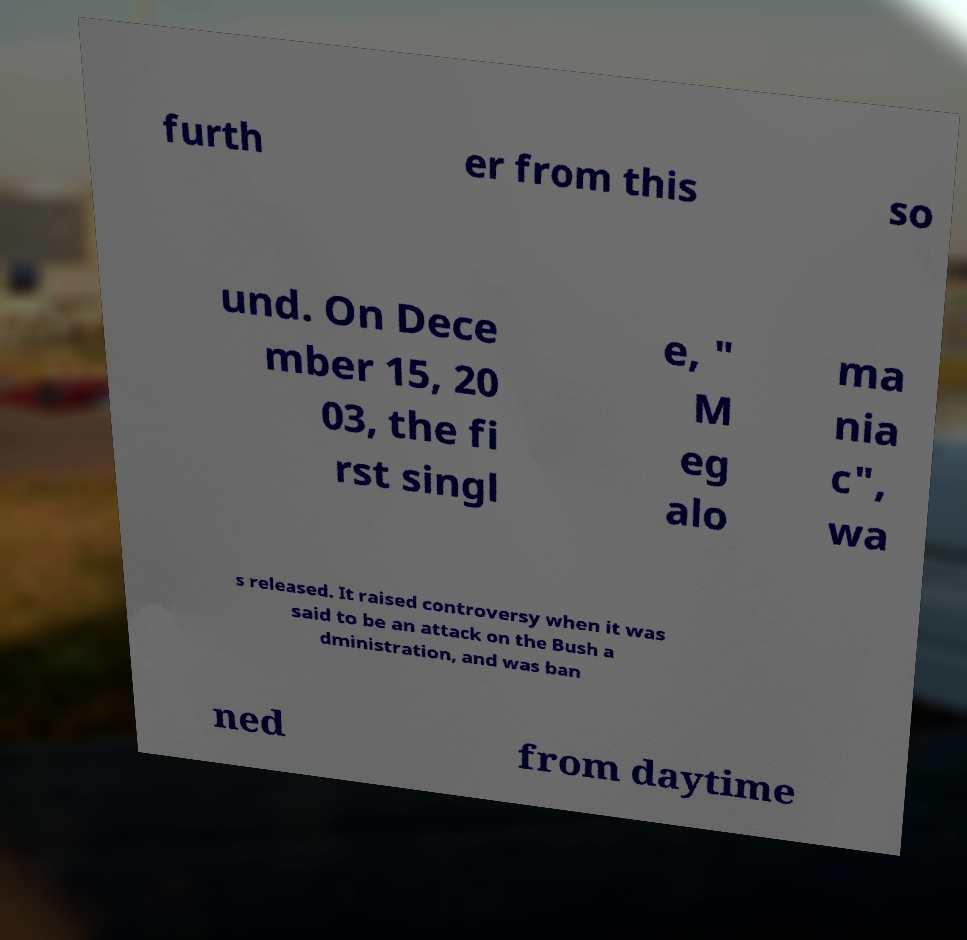For documentation purposes, I need the text within this image transcribed. Could you provide that? furth er from this so und. On Dece mber 15, 20 03, the fi rst singl e, " M eg alo ma nia c", wa s released. It raised controversy when it was said to be an attack on the Bush a dministration, and was ban ned from daytime 